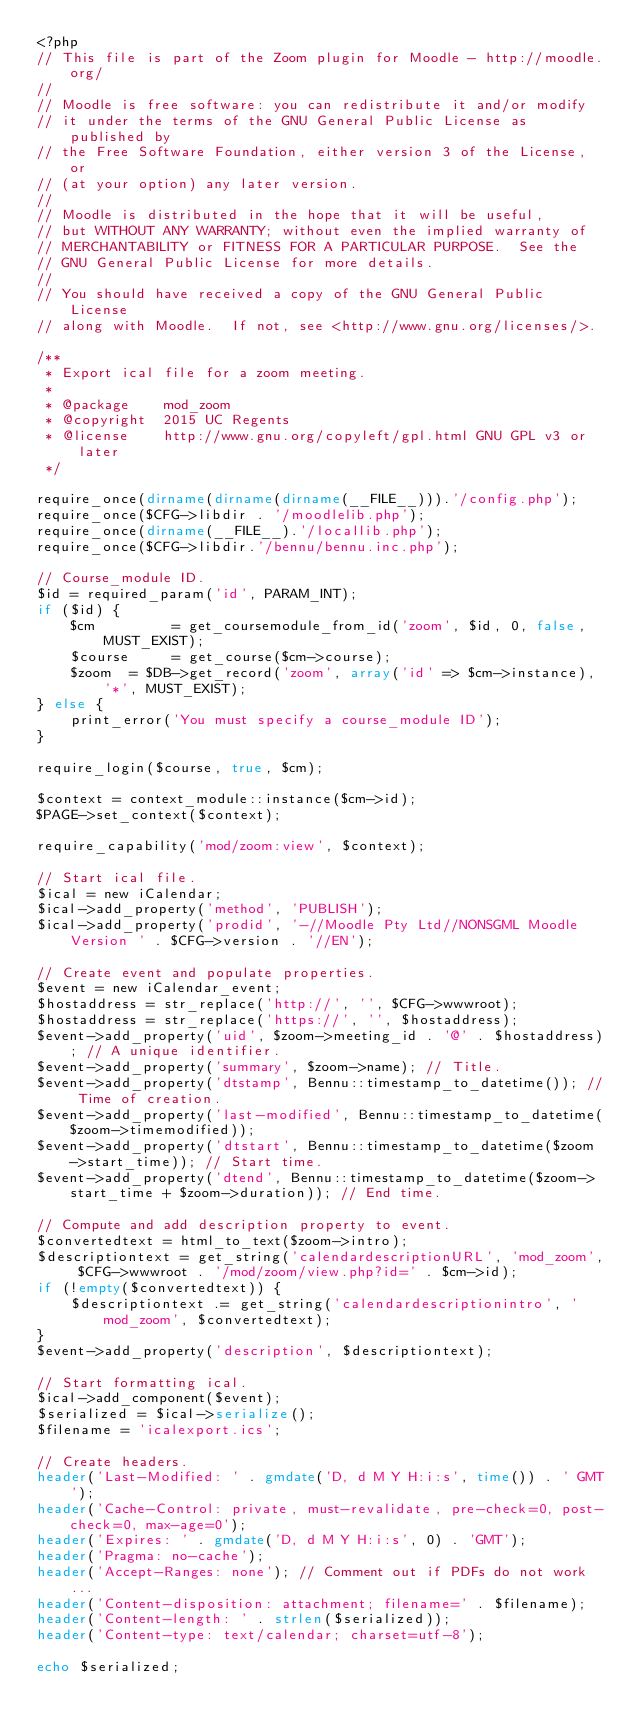Convert code to text. <code><loc_0><loc_0><loc_500><loc_500><_PHP_><?php
// This file is part of the Zoom plugin for Moodle - http://moodle.org/
//
// Moodle is free software: you can redistribute it and/or modify
// it under the terms of the GNU General Public License as published by
// the Free Software Foundation, either version 3 of the License, or
// (at your option) any later version.
//
// Moodle is distributed in the hope that it will be useful,
// but WITHOUT ANY WARRANTY; without even the implied warranty of
// MERCHANTABILITY or FITNESS FOR A PARTICULAR PURPOSE.  See the
// GNU General Public License for more details.
//
// You should have received a copy of the GNU General Public License
// along with Moodle.  If not, see <http://www.gnu.org/licenses/>.

/**
 * Export ical file for a zoom meeting.
 *
 * @package    mod_zoom
 * @copyright  2015 UC Regents
 * @license    http://www.gnu.org/copyleft/gpl.html GNU GPL v3 or later
 */

require_once(dirname(dirname(dirname(__FILE__))).'/config.php');
require_once($CFG->libdir . '/moodlelib.php');
require_once(dirname(__FILE__).'/locallib.php');
require_once($CFG->libdir.'/bennu/bennu.inc.php');

// Course_module ID.
$id = required_param('id', PARAM_INT);
if ($id) {
    $cm         = get_coursemodule_from_id('zoom', $id, 0, false, MUST_EXIST);
    $course     = get_course($cm->course);
    $zoom  = $DB->get_record('zoom', array('id' => $cm->instance), '*', MUST_EXIST);
} else {
    print_error('You must specify a course_module ID');
}

require_login($course, true, $cm);

$context = context_module::instance($cm->id);
$PAGE->set_context($context);

require_capability('mod/zoom:view', $context);

// Start ical file.
$ical = new iCalendar;
$ical->add_property('method', 'PUBLISH');
$ical->add_property('prodid', '-//Moodle Pty Ltd//NONSGML Moodle Version ' . $CFG->version . '//EN');

// Create event and populate properties.
$event = new iCalendar_event;
$hostaddress = str_replace('http://', '', $CFG->wwwroot);
$hostaddress = str_replace('https://', '', $hostaddress);
$event->add_property('uid', $zoom->meeting_id . '@' . $hostaddress); // A unique identifier.
$event->add_property('summary', $zoom->name); // Title.
$event->add_property('dtstamp', Bennu::timestamp_to_datetime()); // Time of creation.
$event->add_property('last-modified', Bennu::timestamp_to_datetime($zoom->timemodified));
$event->add_property('dtstart', Bennu::timestamp_to_datetime($zoom->start_time)); // Start time.
$event->add_property('dtend', Bennu::timestamp_to_datetime($zoom->start_time + $zoom->duration)); // End time.

// Compute and add description property to event.
$convertedtext = html_to_text($zoom->intro);
$descriptiontext = get_string('calendardescriptionURL', 'mod_zoom', $CFG->wwwroot . '/mod/zoom/view.php?id=' . $cm->id);
if (!empty($convertedtext)) {
    $descriptiontext .= get_string('calendardescriptionintro', 'mod_zoom', $convertedtext);
}
$event->add_property('description', $descriptiontext);

// Start formatting ical.
$ical->add_component($event);
$serialized = $ical->serialize();
$filename = 'icalexport.ics';

// Create headers.
header('Last-Modified: ' . gmdate('D, d M Y H:i:s', time()) . ' GMT');
header('Cache-Control: private, must-revalidate, pre-check=0, post-check=0, max-age=0');
header('Expires: ' . gmdate('D, d M Y H:i:s', 0) . 'GMT');
header('Pragma: no-cache');
header('Accept-Ranges: none'); // Comment out if PDFs do not work...
header('Content-disposition: attachment; filename=' . $filename);
header('Content-length: ' . strlen($serialized));
header('Content-type: text/calendar; charset=utf-8');

echo $serialized;
</code> 